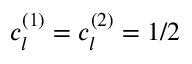<formula> <loc_0><loc_0><loc_500><loc_500>c _ { l } ^ { ( 1 ) } = c _ { l } ^ { ( 2 ) } = 1 / 2</formula> 